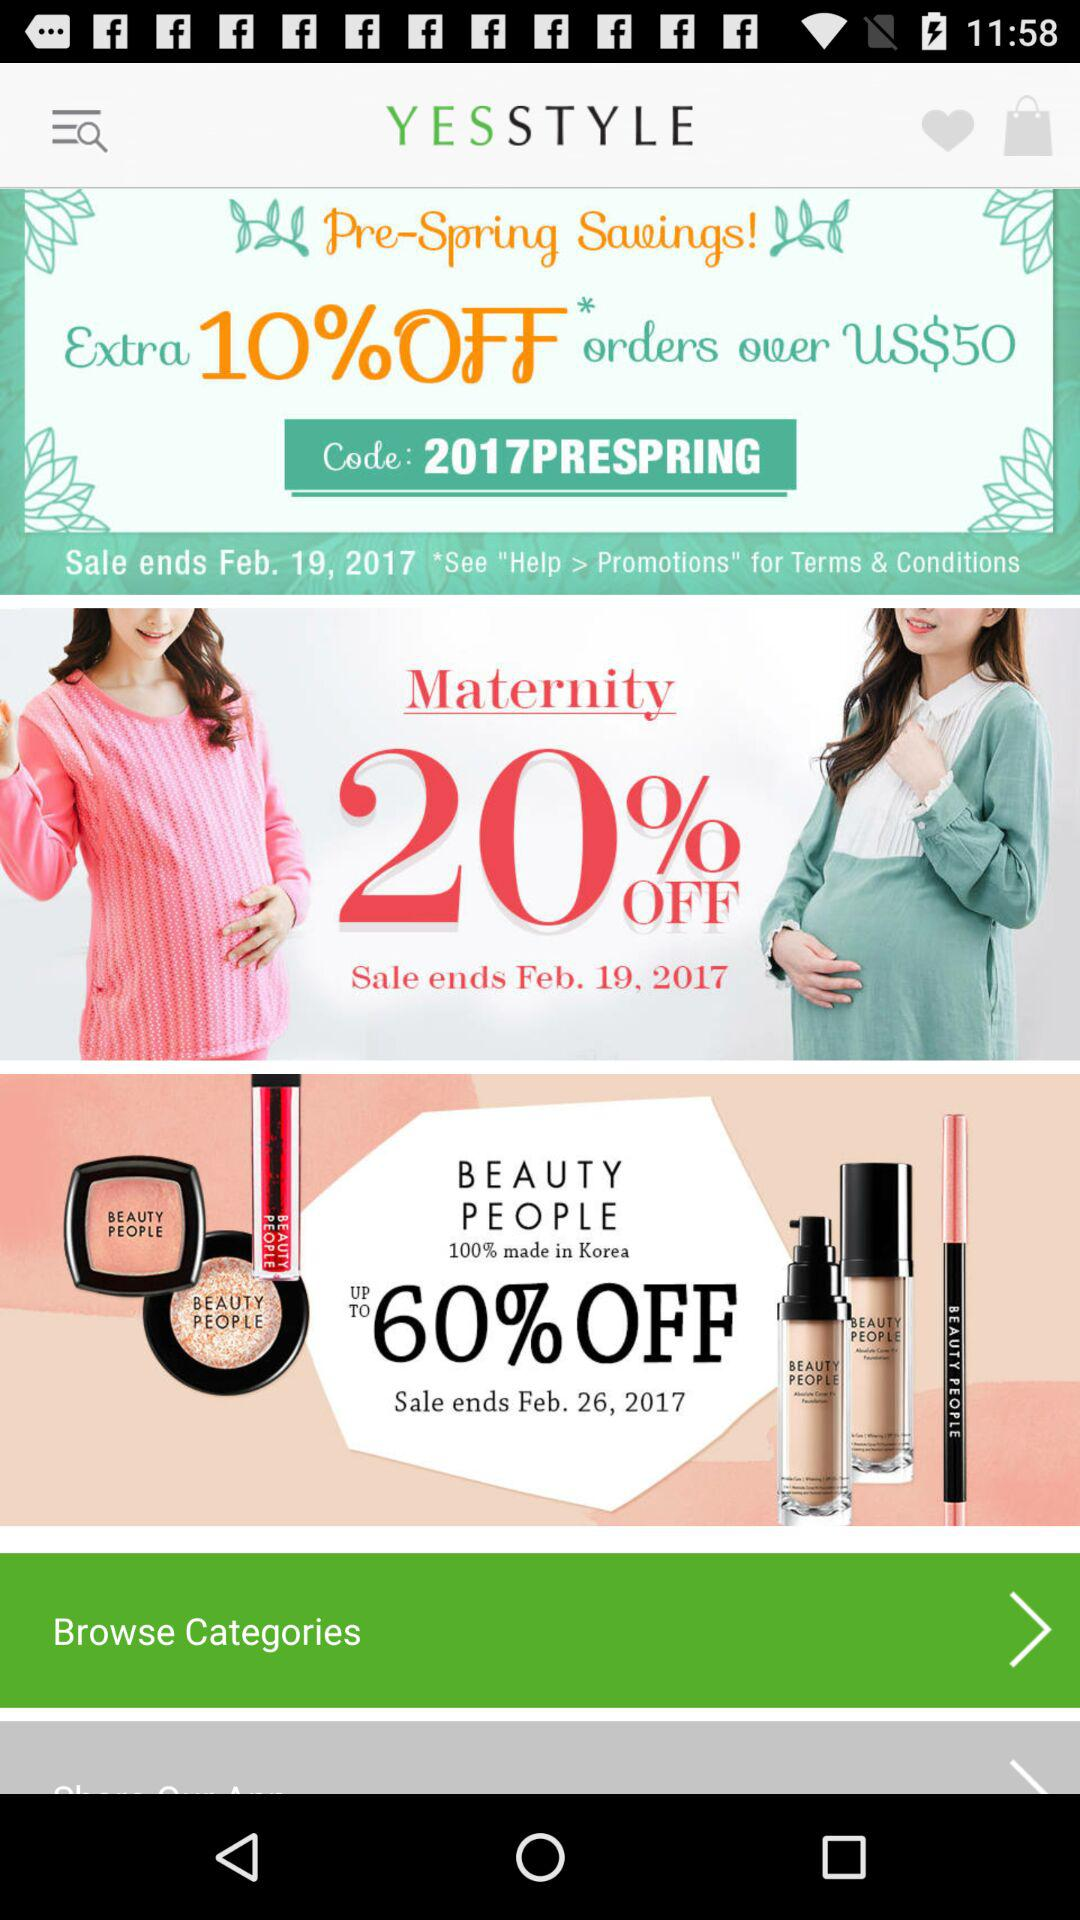What code is used in "Pre-Spring Savings!"? The code is "2017PRESPRING". 